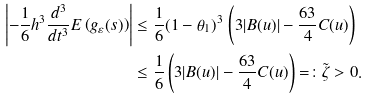<formula> <loc_0><loc_0><loc_500><loc_500>\left | - \frac { 1 } { 6 } h ^ { 3 } \frac { d ^ { 3 } } { d t ^ { 3 } } E \left ( g _ { \varepsilon } ( s ) \right ) \right | & \leq \frac { 1 } { 6 } ( 1 - \theta _ { 1 } ) ^ { 3 } \, \left ( 3 | B ( u ) | - \frac { 6 3 } { 4 } C ( u ) \right ) \\ & \leq \frac { 1 } { 6 } \left ( 3 | B ( u ) | - \frac { 6 3 } { 4 } C ( u ) \right ) = \colon \tilde { \zeta } > 0 .</formula> 